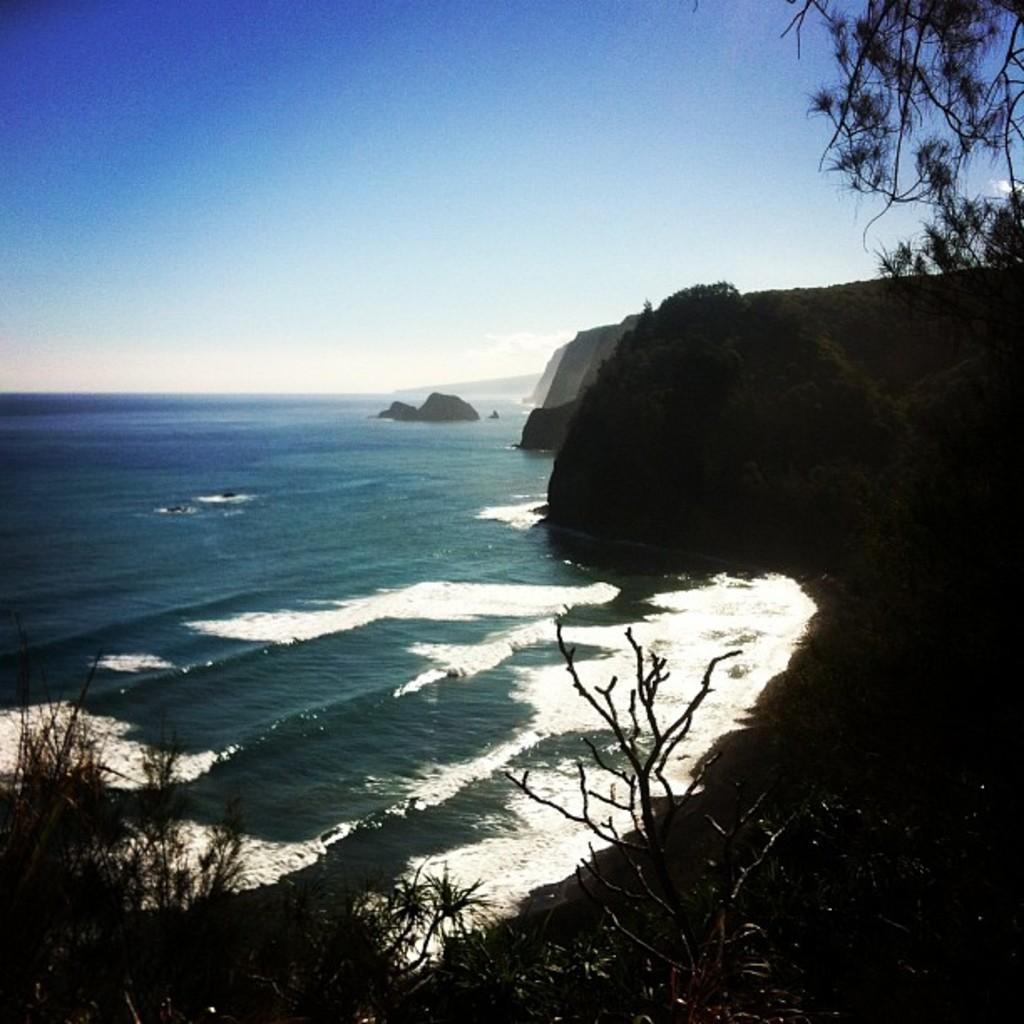In one or two sentences, can you explain what this image depicts? In this image, we can see trees and hills and at the bottom, there is water. At the top, there is sky. 